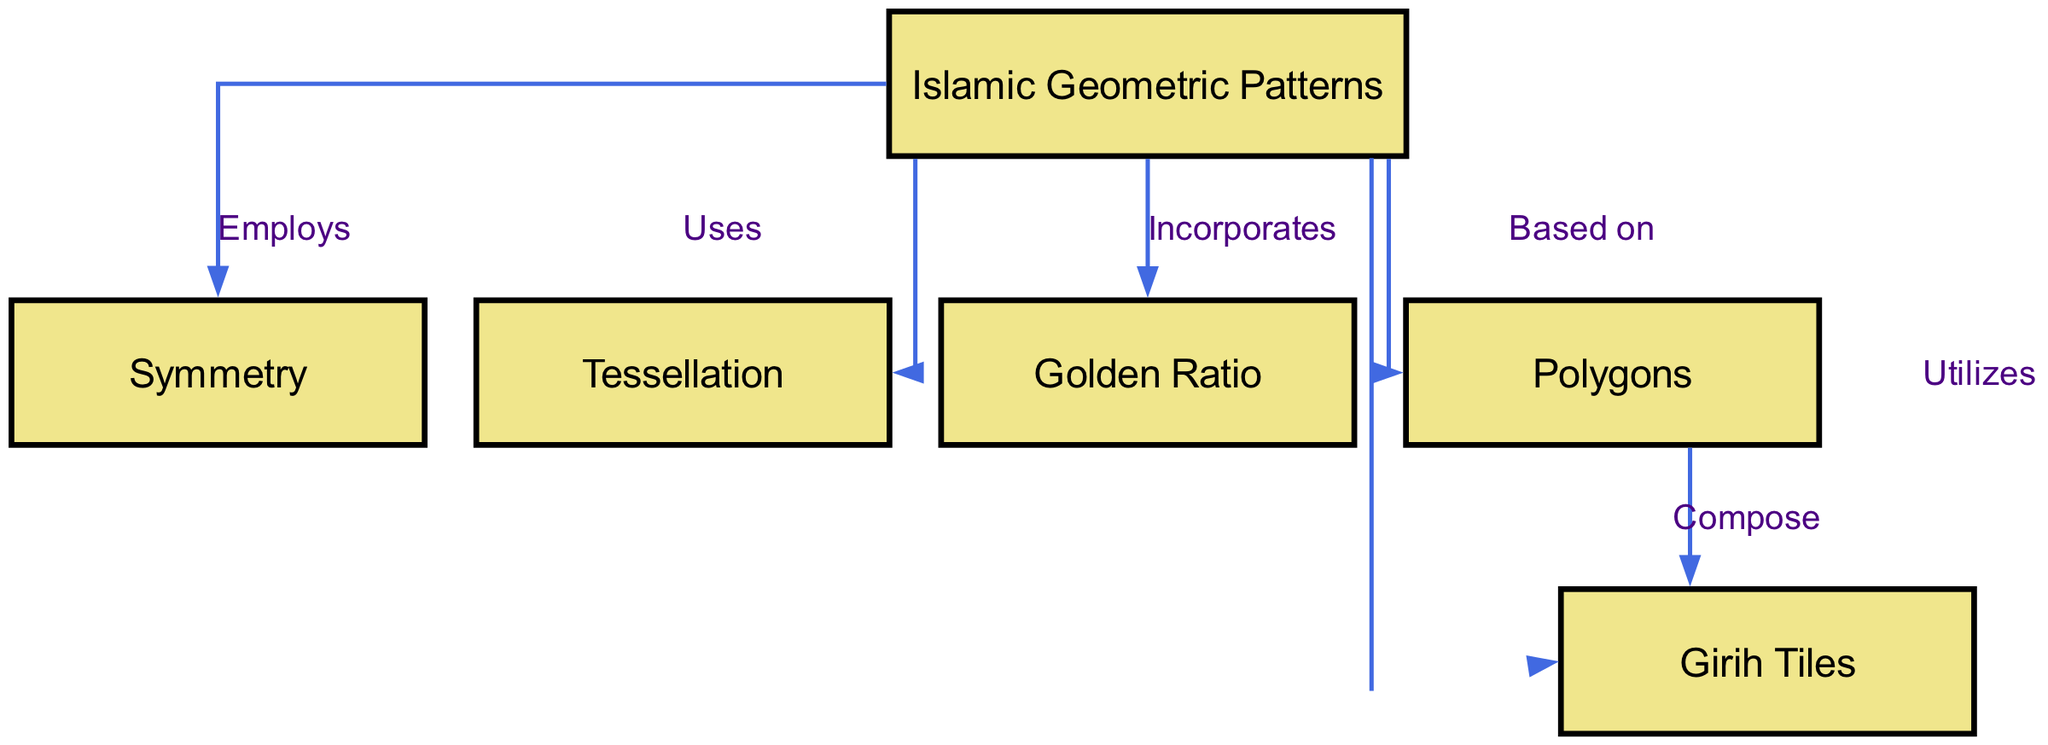What is the central theme of the diagram? The diagram centers around "Islamic Geometric Patterns," which is the main node. This can be determined as it is the starting point from which various mathematical principles and techniques are explained through connections to other nodes.
Answer: Islamic Geometric Patterns How many nodes are present in the diagram? By counting the individual nodes listed in the data, we see there are six nodes: Islamic Geometric Patterns, Symmetry, Tessellation, Golden Ratio, Polygons, and Girih Tiles. Therefore, the total is six nodes.
Answer: 6 What relationship is indicated between "Islamic Geometric Patterns" and "Symmetry"? The relationship is labeled "Employs," indicating that Islamic Geometric Patterns uses symmetry as a key component in their design and structure. This relationship can be tracked by following the directed edge connecting the two nodes.
Answer: Employs Which principle is incorporated into Islamic Geometric Patterns? The diagram shows that the "Golden Ratio" is one of the underlying mathematical principles incorporated into Islamic Geometric Patterns. This can be seen through the direct edge linking both nodes under the label "Incorporates."
Answer: Golden Ratio What do "Polygons" and "Girih Tiles" do in the context of the diagram? "Polygons" serve as the foundational shapes that compose "Girih Tiles." This can be understood through the edge labeled "Compose" that connects the two nodes, indicating that polygons are the building blocks of Girih tiles.
Answer: Compose How do "Islamic Geometric Patterns" and "Tessellation" relate? The relationship is labeled "Uses," which suggests that Islamic Geometric Patterns utilize tessellation in their designs. Following the corresponding edge in the diagram confirms this relationship.
Answer: Uses What type of tile is utilized in Islamic Geometric Patterns? The diagram indicates the use of "Girih Tiles" as a specific type of tiling method employed in Islamic Geometric Patterns. This is reflected in the directed edge labeled "Utilizes" connecting the main node to Girih Tiles.
Answer: Girih Tiles What mathematical concept is associated with the polygons in the diagram? The concept of "Symmetry" is associated with polygons, shown by the directed edge that indicates polygons' relation to symmetry. This means polygons in their design involve symmetrical qualities.
Answer: Symmetry What is the relationship between "Polygons" and "Symmetry"? "Polygons" are connected to "Symmetry" through their inherent geometrical properties, which are relevant to Islamic art patterns. This relationship is inferred through the composition of patterns that often takes into account symmetrical arrangements of polygons.
Answer: Symmetrical 